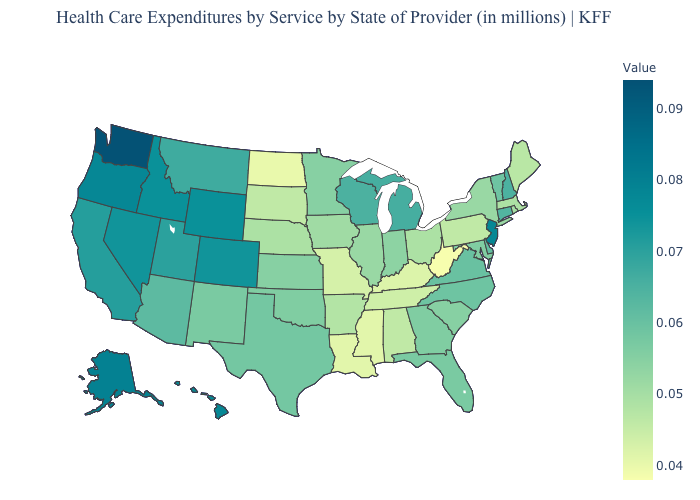Does Nebraska have a lower value than Wyoming?
Quick response, please. Yes. Does Ohio have the highest value in the MidWest?
Answer briefly. No. Which states hav the highest value in the South?
Write a very short answer. Delaware. Does the map have missing data?
Short answer required. No. Does Connecticut have a higher value than Rhode Island?
Keep it brief. Yes. Among the states that border New Hampshire , which have the highest value?
Write a very short answer. Vermont. 